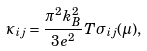<formula> <loc_0><loc_0><loc_500><loc_500>\kappa _ { i j } = \frac { \pi ^ { 2 } k _ { B } ^ { 2 } } { 3 e ^ { 2 } } T \sigma _ { i j } ( \mu ) ,</formula> 